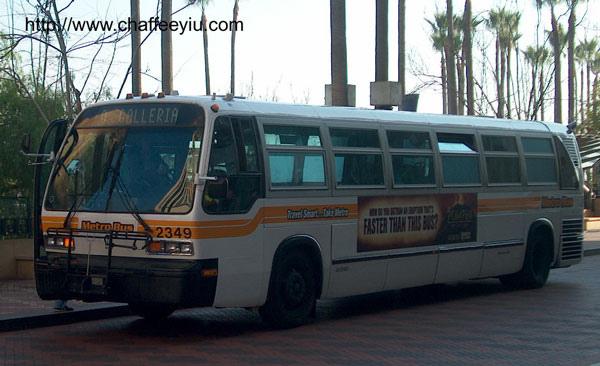What does the advertisement on the side of the bus say?
Give a very brief answer. Faster than this bus. How many people are in this vehicle?
Short answer required. 0. Where is the terminal for this bus?
Quick response, please. Galleria. What kind of vehicle is this?
Concise answer only. Bus. 